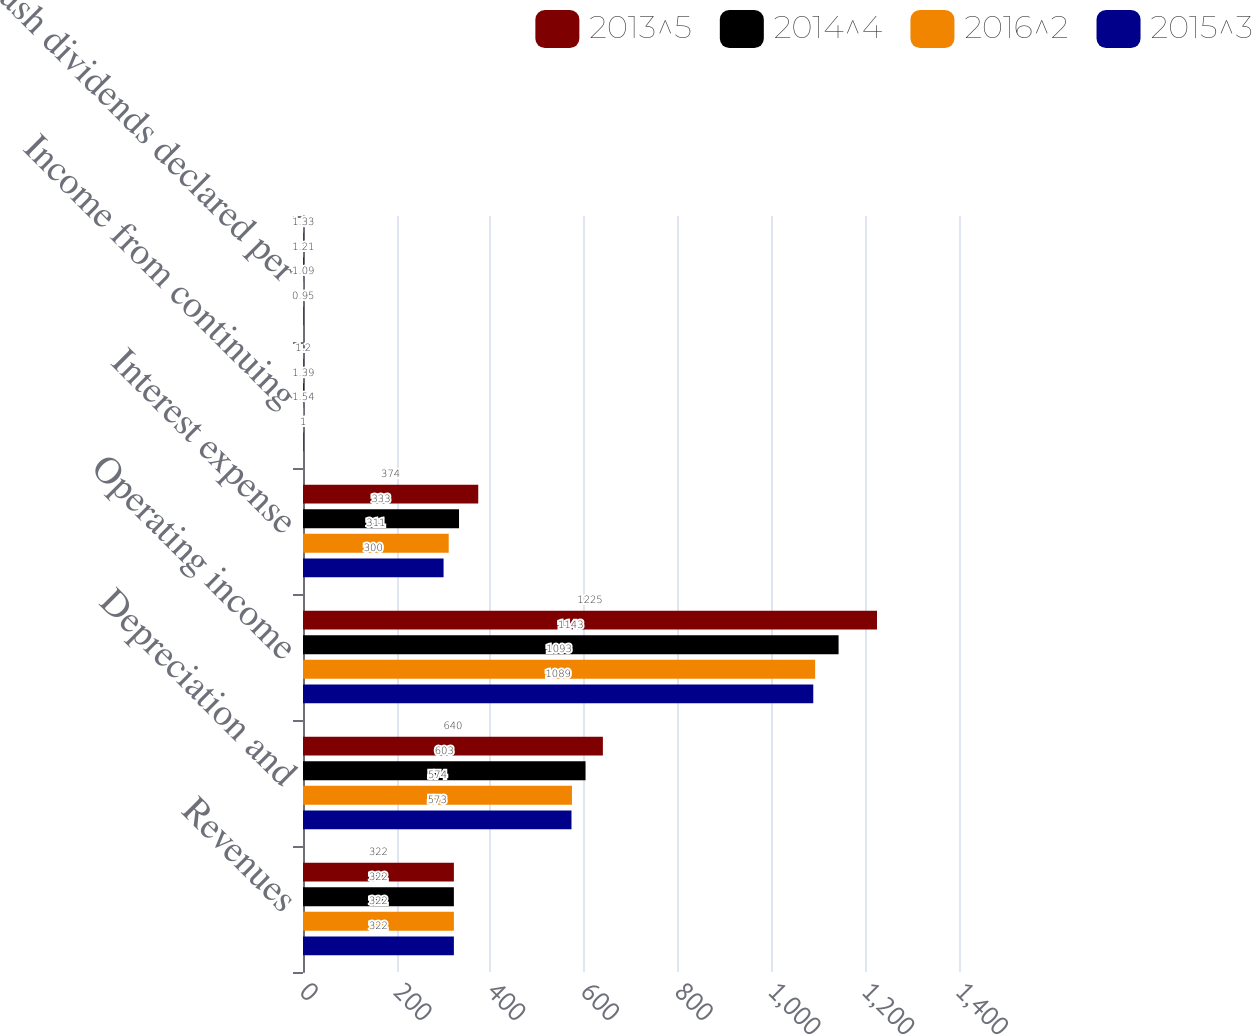<chart> <loc_0><loc_0><loc_500><loc_500><stacked_bar_chart><ecel><fcel>Revenues<fcel>Depreciation and<fcel>Operating income<fcel>Interest expense<fcel>Income from continuing<fcel>Cash dividends declared per<nl><fcel>2013^5<fcel>322<fcel>640<fcel>1225<fcel>374<fcel>1.2<fcel>1.33<nl><fcel>2014^4<fcel>322<fcel>603<fcel>1143<fcel>333<fcel>1.39<fcel>1.21<nl><fcel>2016^2<fcel>322<fcel>574<fcel>1093<fcel>311<fcel>1.54<fcel>1.09<nl><fcel>2015^3<fcel>322<fcel>573<fcel>1089<fcel>300<fcel>1<fcel>0.95<nl></chart> 